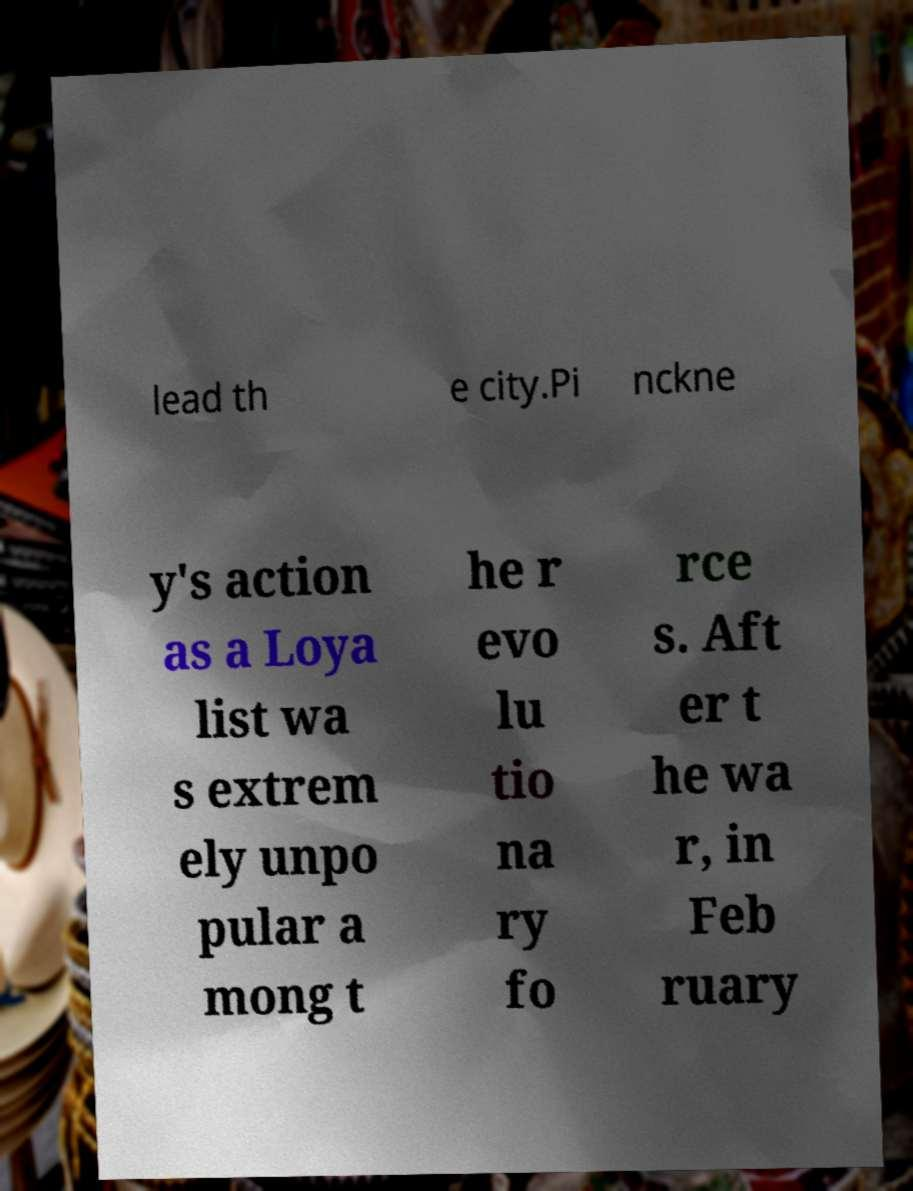Could you extract and type out the text from this image? lead th e city.Pi nckne y's action as a Loya list wa s extrem ely unpo pular a mong t he r evo lu tio na ry fo rce s. Aft er t he wa r, in Feb ruary 